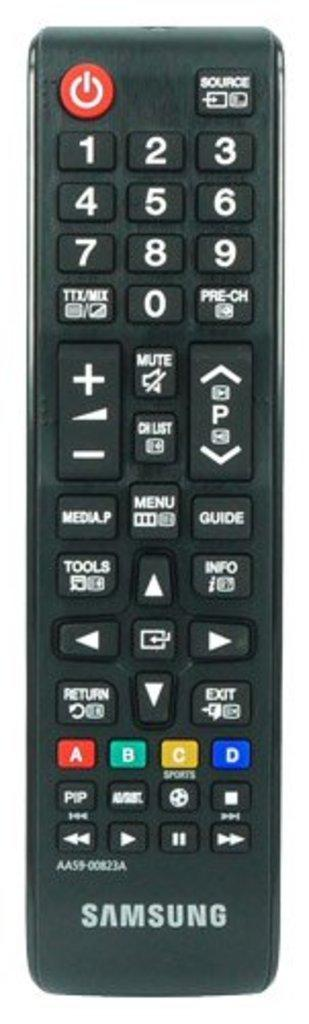What object is visible in the image? There is a TV remote in the image. What is the primary function of the object in the image? The TV remote is used to control a television. Can you describe the appearance of the object in the image? The TV remote appears to be a small, handheld device with buttons. How many cars are parked next to the TV remote in the image? There are no cars present in the image; it only features a TV remote. What type of pickle is being used to control the TV in the image? There is no pickle present in the image; it only features a TV remote. 